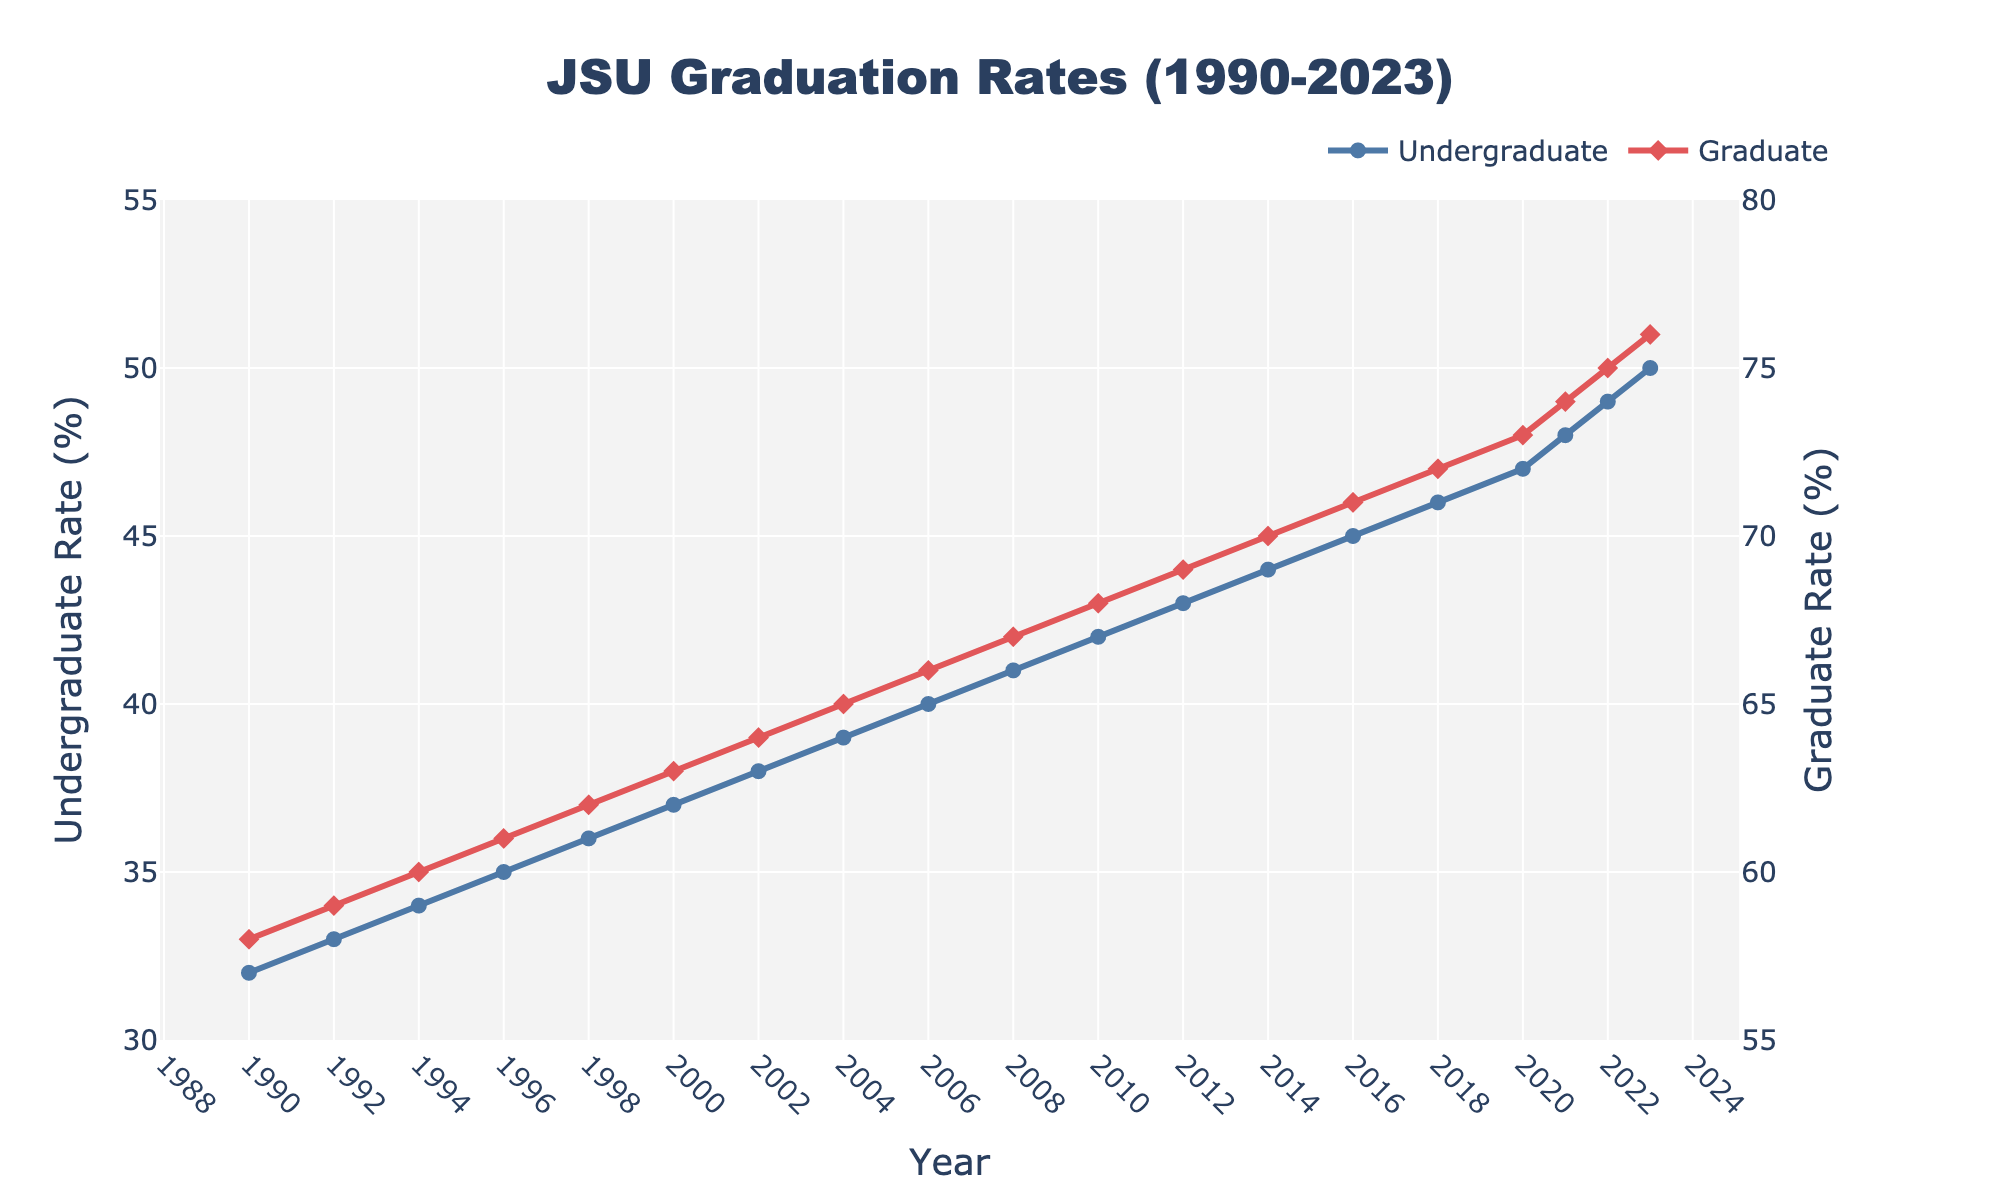What's the overall trend in undergraduate and graduate graduation rates from 1990 to 2023? Both undergraduate and graduate graduation rates show an increasing trend from 1990 to 2023.
Answer: Increasing Which program had a higher graduation rate in 1990, undergraduate or graduate? In 1990, the graduation rate for the undergraduate program was 32%, while for the graduate program it was 58%. The graduate program had a higher rate.
Answer: Graduate By how much did the undergraduate graduation rate increase from 1990 to 2023? The undergraduate graduation rate increased from 32% in 1990 to 50% in 2023. The increase is 50 - 32 = 18%.
Answer: 18% When did the undergraduate graduation rate reach 45%? According to the chart, the undergraduate graduation rate reached 45% in the year 2016.
Answer: 2016 What is the average graduation rate for graduate programs between 1990 and 2023? To find the average graduation rate for graduate programs, sum all the graduate rates and divide by the number of years:
(58 + 59 + 60 + 61 + 62 + 63 + 64 + 65 + 66 + 67 + 68 + 69 + 70 + 71 + 72 + 73 + 74 + 75 + 76) / 19 = 67.42% (approximately).
Answer: 67.42% How do the rates for undergraduate and graduate programs compare in 2010? In 2010, the undergraduate graduation rate was 42% and the graduate rate was 68%. The graduate rate was significantly higher than the undergraduate rate.
Answer: Graduate rate higher What was the difference in graduation rates between the undergraduate and graduate programs in 2020? In 2020, the undergraduate graduation rate was 47% and the graduate rate was 73%. The difference is 73 - 47 = 26%.
Answer: 26% Which year had the smallest gap between undergraduate and graduate graduation rates? The smallest gap was observed in 1990 where the undergraduate rate was 32% and the graduate rate was 58%, resulting in a gap of 26%. This is the smallest as the gap only widens in the subsequent years.
Answer: 1990 What's the average annual increase in the undergraduate graduation rate over the period from 1990 to 2023? The undergraduate rate increased from 32% in 1990 to 50% in 2023. The total increase is 18% over 33 years. The average annual increase is 18 / 33 ≈ 0.545%.
Answer: 0.545% Which program showed a greater overall increase in graduation rates by 2023, and by how much? The undergraduate rate increased from 32% in 1990 to 50% in 2023, an increase of 18%. The graduate rate increased from 58% to 76%, also an increase of 18%. Thus, both programs had the same overall increase of 18%.
Answer: Both, 18% 